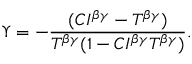Convert formula to latex. <formula><loc_0><loc_0><loc_500><loc_500>\Upsilon = - \frac { ( C I ^ { \beta \gamma } - T ^ { \beta \gamma } ) } { T ^ { \beta \gamma } ( 1 - C I ^ { \beta \gamma } T ^ { \beta \gamma } ) } .</formula> 